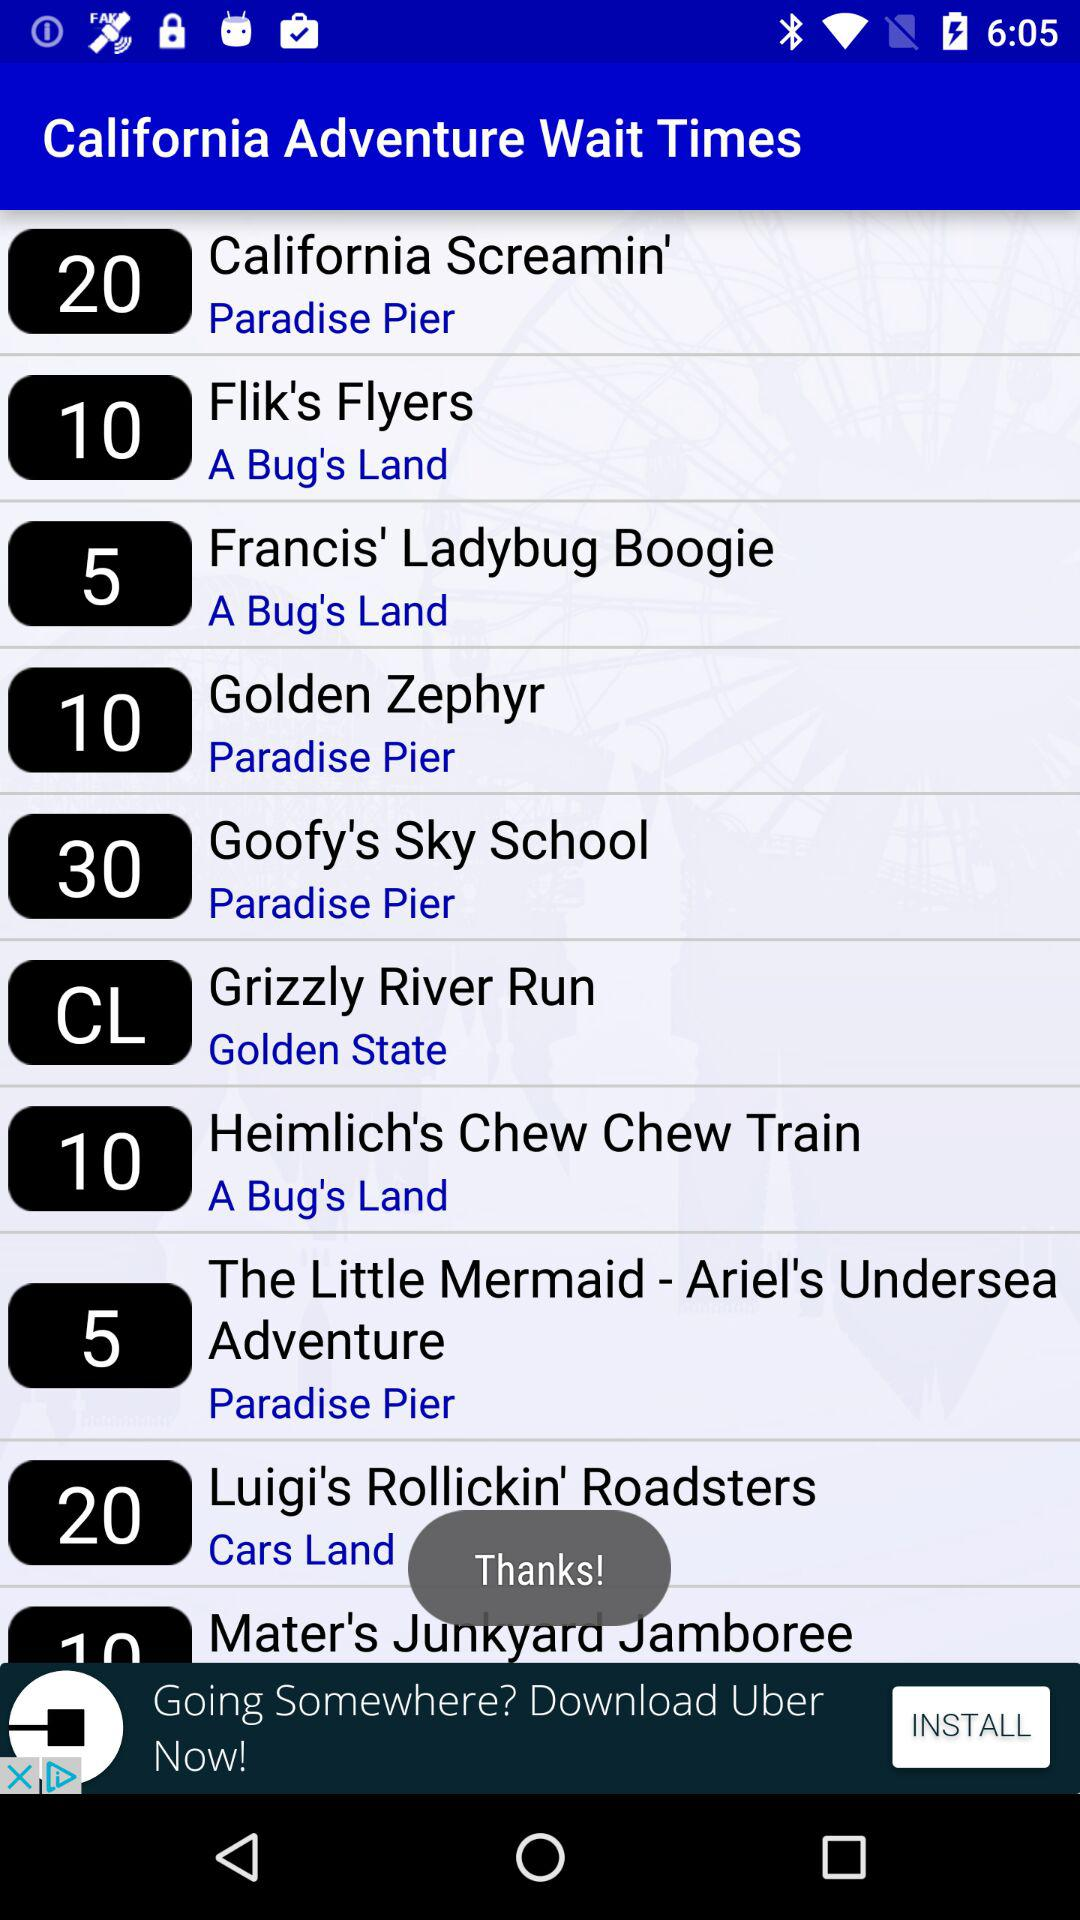What is the wait time for "California Screamin'"? The wait time for "California Screamin'" is 20. 